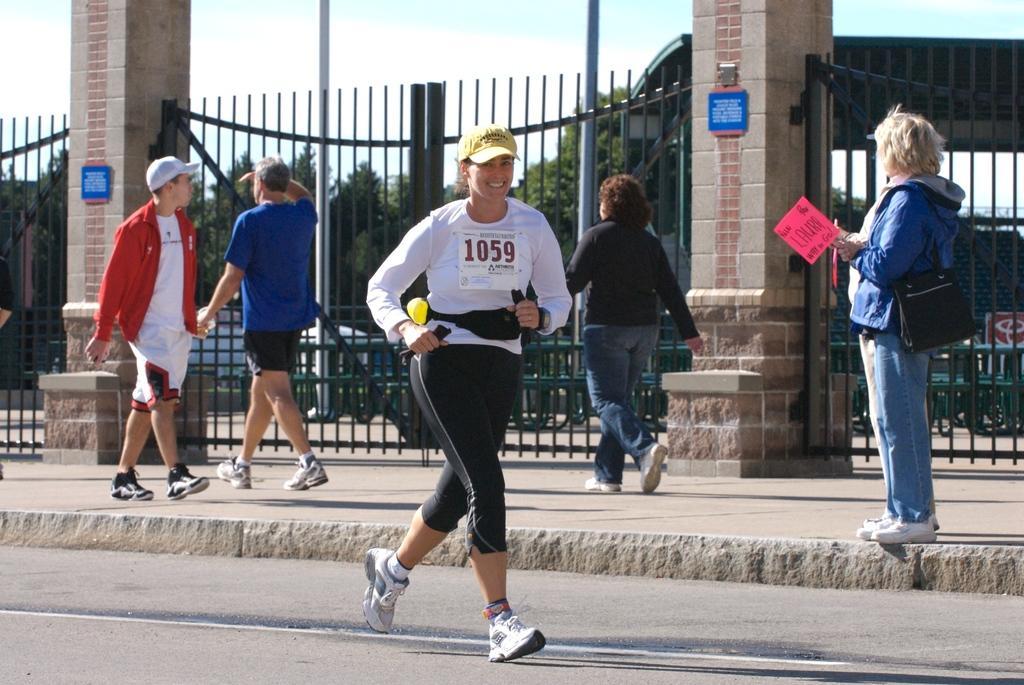Could you give a brief overview of what you see in this image? In this image there is a woman running on a road, in the background there are people walking on a footpath and there is a railing, pillars, trees and the sky. 